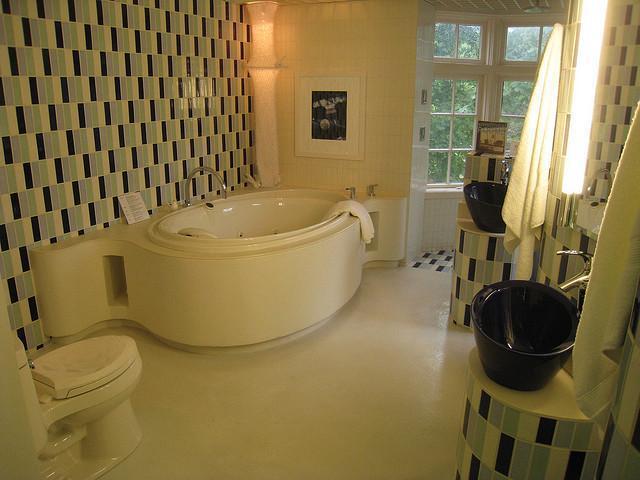How many urinals are visible?
Give a very brief answer. 0. 